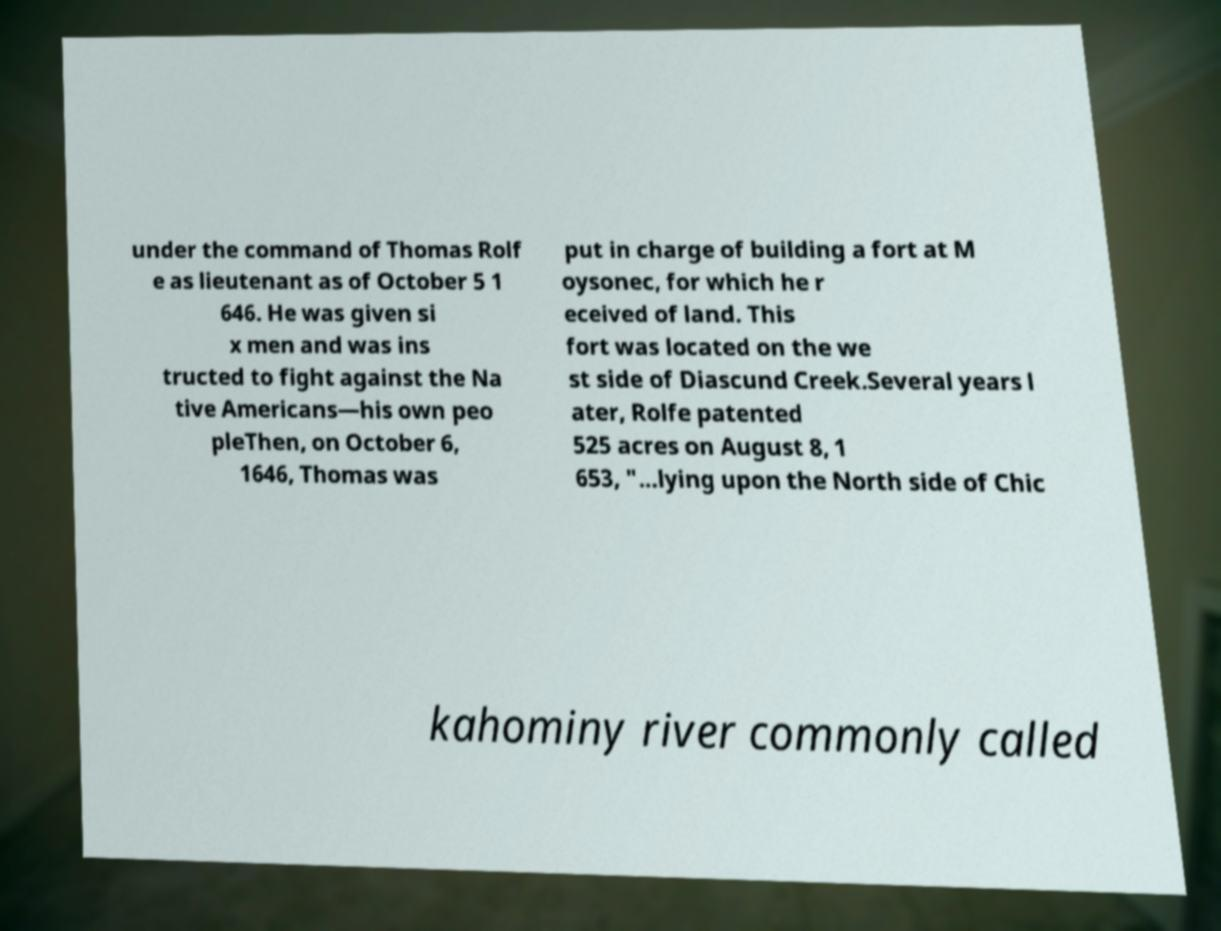Could you extract and type out the text from this image? under the command of Thomas Rolf e as lieutenant as of October 5 1 646. He was given si x men and was ins tructed to fight against the Na tive Americans—his own peo pleThen, on October 6, 1646, Thomas was put in charge of building a fort at M oysonec, for which he r eceived of land. This fort was located on the we st side of Diascund Creek.Several years l ater, Rolfe patented 525 acres on August 8, 1 653, "...lying upon the North side of Chic kahominy river commonly called 